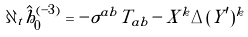<formula> <loc_0><loc_0><loc_500><loc_500>\partial _ { t } \hat { h } ^ { ( - 3 ) } _ { 0 } = - \tilde { \sigma } ^ { a b } T _ { a b } - \tilde { X } ^ { k } \tilde { \Delta } ( Y ^ { \prime } ) ^ { k }</formula> 